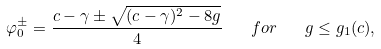<formula> <loc_0><loc_0><loc_500><loc_500>\varphi _ { 0 } ^ { \pm } = \frac { c - \gamma \pm \sqrt { ( c - \gamma ) ^ { 2 } - 8 g } } { 4 } \quad f o r \quad g \leq g _ { 1 } ( c ) ,</formula> 